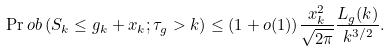<formula> <loc_0><loc_0><loc_500><loc_500>\Pr o b \left ( S _ { k } \leq g _ { k } + x _ { k } ; \tau _ { g } > k \right ) \leq ( 1 + o ( 1 ) ) \frac { x _ { k } ^ { 2 } } { \sqrt { 2 \pi } } \frac { L _ { g } ( k ) } { k ^ { 3 / 2 } } .</formula> 